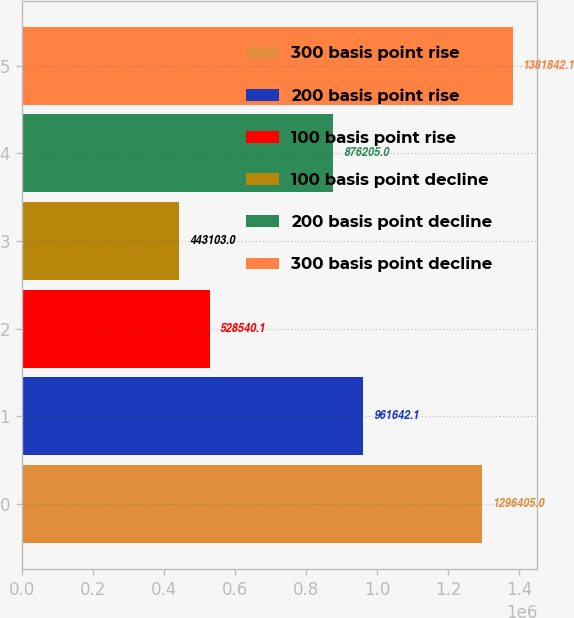Convert chart. <chart><loc_0><loc_0><loc_500><loc_500><bar_chart><fcel>300 basis point rise<fcel>200 basis point rise<fcel>100 basis point rise<fcel>100 basis point decline<fcel>200 basis point decline<fcel>300 basis point decline<nl><fcel>1.2964e+06<fcel>961642<fcel>528540<fcel>443103<fcel>876205<fcel>1.38184e+06<nl></chart> 